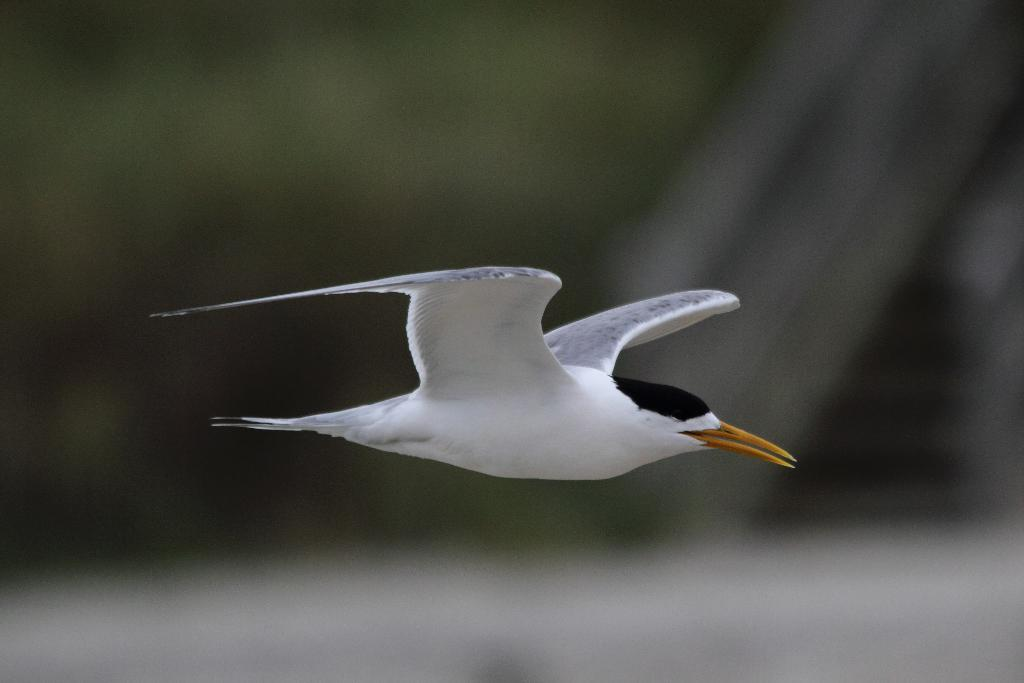What is the main subject in the center of the image? There is a bird in the center of the image. Where is the playground located in the image? There is no playground present in the image; it only features a bird. What type of fruit can be seen hanging from the bird's beak in the image? There is no fruit, such as an apple, present in the image, nor is the bird holding anything in its beak. 